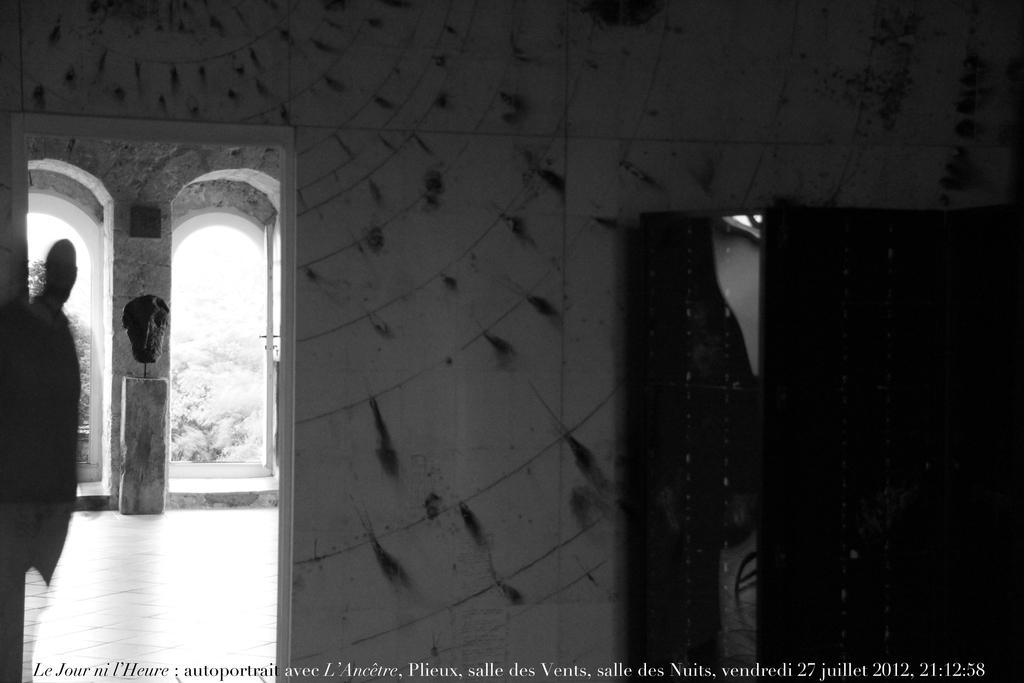In one or two sentences, can you explain what this image depicts? This is a black and white pic. On the left side we can see the blur image of a person and on the right side there is a mirror on an object and we can see the wall. In the background there are trees on the left side. At the bottom there is a text written on the image. 